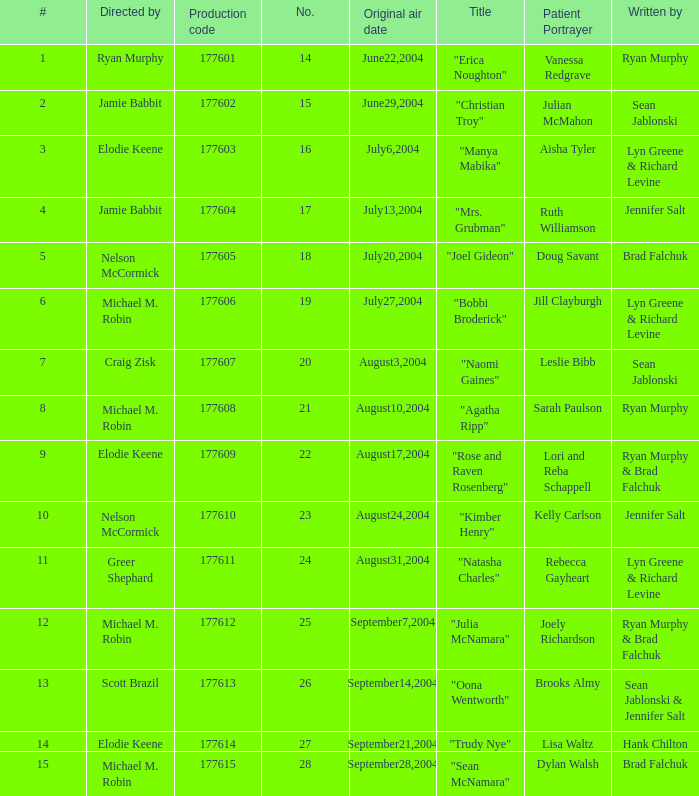What numbered episode is titled "naomi gaines"? 20.0. 